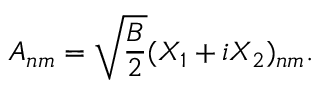Convert formula to latex. <formula><loc_0><loc_0><loc_500><loc_500>A _ { n m } = \sqrt { \frac { B } { 2 } } ( X _ { 1 } + i X _ { 2 } ) _ { n m } .</formula> 